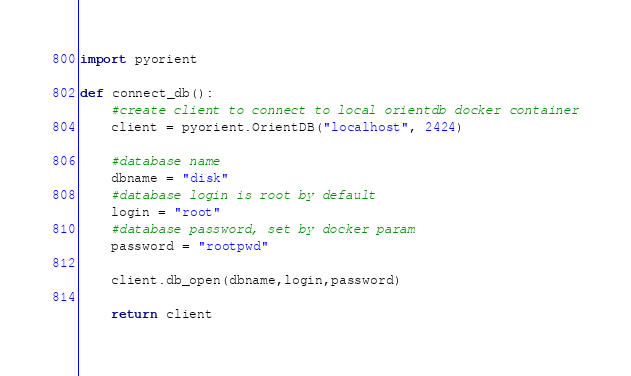Convert code to text. <code><loc_0><loc_0><loc_500><loc_500><_Python_>import pyorient

def connect_db():
    #create client to connect to local orientdb docker container
    client = pyorient.OrientDB("localhost", 2424)

    #database name
    dbname = "disk"
    #database login is root by default
    login = "root"
    #database password, set by docker param
    password = "rootpwd"

    client.db_open(dbname,login,password)

    return client</code> 